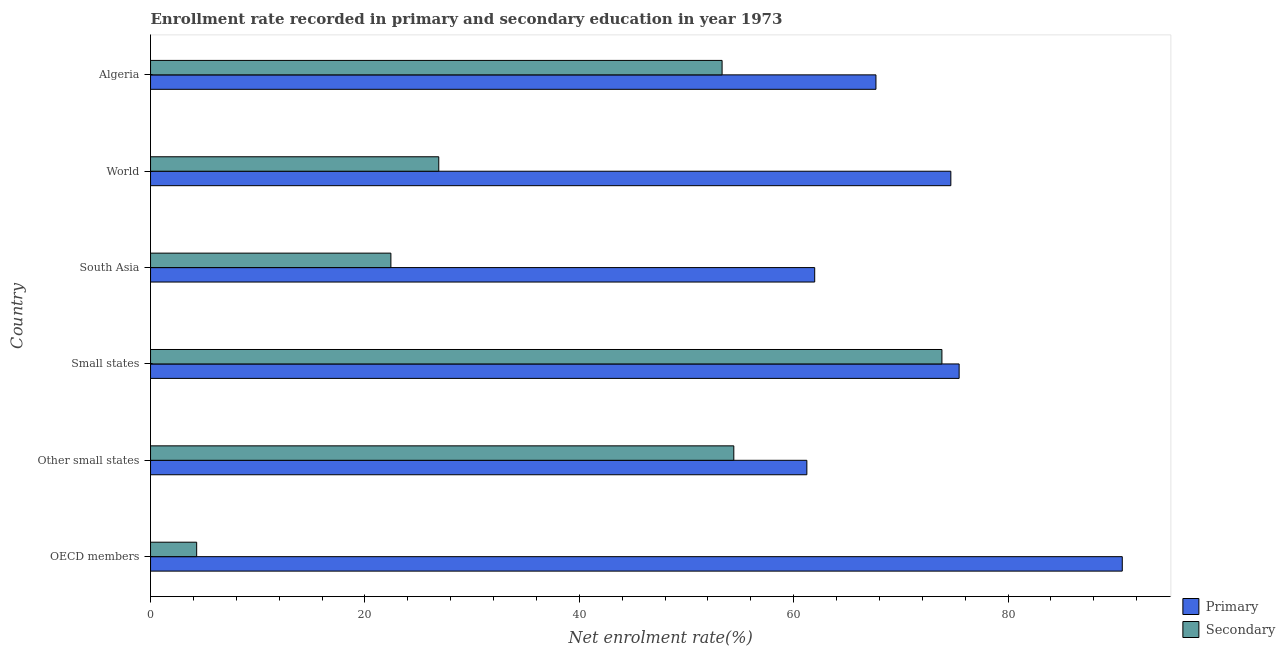How many bars are there on the 2nd tick from the top?
Offer a terse response. 2. How many bars are there on the 4th tick from the bottom?
Keep it short and to the point. 2. What is the label of the 4th group of bars from the top?
Provide a succinct answer. Small states. In how many cases, is the number of bars for a given country not equal to the number of legend labels?
Give a very brief answer. 0. What is the enrollment rate in secondary education in Small states?
Provide a short and direct response. 73.83. Across all countries, what is the maximum enrollment rate in primary education?
Your response must be concise. 90.66. Across all countries, what is the minimum enrollment rate in primary education?
Provide a short and direct response. 61.23. In which country was the enrollment rate in primary education minimum?
Offer a terse response. Other small states. What is the total enrollment rate in secondary education in the graph?
Make the answer very short. 235.18. What is the difference between the enrollment rate in secondary education in OECD members and that in Other small states?
Your response must be concise. -50.11. What is the difference between the enrollment rate in primary education in OECD members and the enrollment rate in secondary education in Algeria?
Your answer should be very brief. 37.33. What is the average enrollment rate in primary education per country?
Provide a succinct answer. 71.94. What is the difference between the enrollment rate in secondary education and enrollment rate in primary education in OECD members?
Give a very brief answer. -86.35. In how many countries, is the enrollment rate in secondary education greater than 48 %?
Make the answer very short. 3. What is the ratio of the enrollment rate in secondary education in Other small states to that in Small states?
Provide a short and direct response. 0.74. Is the difference between the enrollment rate in primary education in OECD members and Other small states greater than the difference between the enrollment rate in secondary education in OECD members and Other small states?
Make the answer very short. Yes. What is the difference between the highest and the second highest enrollment rate in secondary education?
Make the answer very short. 19.42. What is the difference between the highest and the lowest enrollment rate in primary education?
Offer a very short reply. 29.43. Is the sum of the enrollment rate in primary education in OECD members and World greater than the maximum enrollment rate in secondary education across all countries?
Provide a short and direct response. Yes. What does the 2nd bar from the top in Algeria represents?
Keep it short and to the point. Primary. What does the 2nd bar from the bottom in OECD members represents?
Offer a very short reply. Secondary. Are all the bars in the graph horizontal?
Make the answer very short. Yes. How many countries are there in the graph?
Provide a succinct answer. 6. Does the graph contain any zero values?
Offer a very short reply. No. Where does the legend appear in the graph?
Make the answer very short. Bottom right. How many legend labels are there?
Your answer should be very brief. 2. What is the title of the graph?
Provide a succinct answer. Enrollment rate recorded in primary and secondary education in year 1973. Does "Private consumption" appear as one of the legend labels in the graph?
Offer a terse response. No. What is the label or title of the X-axis?
Your answer should be compact. Net enrolment rate(%). What is the Net enrolment rate(%) in Primary in OECD members?
Offer a terse response. 90.66. What is the Net enrolment rate(%) of Secondary in OECD members?
Ensure brevity in your answer.  4.3. What is the Net enrolment rate(%) of Primary in Other small states?
Provide a succinct answer. 61.23. What is the Net enrolment rate(%) in Secondary in Other small states?
Make the answer very short. 54.41. What is the Net enrolment rate(%) in Primary in Small states?
Offer a very short reply. 75.44. What is the Net enrolment rate(%) of Secondary in Small states?
Provide a succinct answer. 73.83. What is the Net enrolment rate(%) of Primary in South Asia?
Keep it short and to the point. 61.96. What is the Net enrolment rate(%) in Secondary in South Asia?
Provide a succinct answer. 22.42. What is the Net enrolment rate(%) in Primary in World?
Your response must be concise. 74.66. What is the Net enrolment rate(%) of Secondary in World?
Your answer should be compact. 26.89. What is the Net enrolment rate(%) in Primary in Algeria?
Make the answer very short. 67.68. What is the Net enrolment rate(%) in Secondary in Algeria?
Offer a very short reply. 53.32. Across all countries, what is the maximum Net enrolment rate(%) in Primary?
Provide a short and direct response. 90.66. Across all countries, what is the maximum Net enrolment rate(%) in Secondary?
Provide a short and direct response. 73.83. Across all countries, what is the minimum Net enrolment rate(%) of Primary?
Ensure brevity in your answer.  61.23. Across all countries, what is the minimum Net enrolment rate(%) of Secondary?
Your answer should be compact. 4.3. What is the total Net enrolment rate(%) in Primary in the graph?
Offer a terse response. 431.62. What is the total Net enrolment rate(%) in Secondary in the graph?
Offer a terse response. 235.18. What is the difference between the Net enrolment rate(%) in Primary in OECD members and that in Other small states?
Provide a succinct answer. 29.43. What is the difference between the Net enrolment rate(%) in Secondary in OECD members and that in Other small states?
Ensure brevity in your answer.  -50.11. What is the difference between the Net enrolment rate(%) in Primary in OECD members and that in Small states?
Ensure brevity in your answer.  15.22. What is the difference between the Net enrolment rate(%) of Secondary in OECD members and that in Small states?
Make the answer very short. -69.53. What is the difference between the Net enrolment rate(%) in Primary in OECD members and that in South Asia?
Keep it short and to the point. 28.69. What is the difference between the Net enrolment rate(%) of Secondary in OECD members and that in South Asia?
Keep it short and to the point. -18.12. What is the difference between the Net enrolment rate(%) in Primary in OECD members and that in World?
Offer a terse response. 15.99. What is the difference between the Net enrolment rate(%) of Secondary in OECD members and that in World?
Make the answer very short. -22.59. What is the difference between the Net enrolment rate(%) in Primary in OECD members and that in Algeria?
Your answer should be very brief. 22.98. What is the difference between the Net enrolment rate(%) of Secondary in OECD members and that in Algeria?
Your response must be concise. -49.02. What is the difference between the Net enrolment rate(%) of Primary in Other small states and that in Small states?
Ensure brevity in your answer.  -14.21. What is the difference between the Net enrolment rate(%) in Secondary in Other small states and that in Small states?
Your answer should be compact. -19.42. What is the difference between the Net enrolment rate(%) in Primary in Other small states and that in South Asia?
Provide a short and direct response. -0.73. What is the difference between the Net enrolment rate(%) of Secondary in Other small states and that in South Asia?
Give a very brief answer. 31.99. What is the difference between the Net enrolment rate(%) in Primary in Other small states and that in World?
Provide a short and direct response. -13.43. What is the difference between the Net enrolment rate(%) of Secondary in Other small states and that in World?
Make the answer very short. 27.53. What is the difference between the Net enrolment rate(%) of Primary in Other small states and that in Algeria?
Your answer should be compact. -6.45. What is the difference between the Net enrolment rate(%) of Secondary in Other small states and that in Algeria?
Keep it short and to the point. 1.09. What is the difference between the Net enrolment rate(%) of Primary in Small states and that in South Asia?
Your answer should be compact. 13.47. What is the difference between the Net enrolment rate(%) in Secondary in Small states and that in South Asia?
Ensure brevity in your answer.  51.41. What is the difference between the Net enrolment rate(%) in Primary in Small states and that in World?
Make the answer very short. 0.77. What is the difference between the Net enrolment rate(%) in Secondary in Small states and that in World?
Your response must be concise. 46.94. What is the difference between the Net enrolment rate(%) in Primary in Small states and that in Algeria?
Provide a succinct answer. 7.76. What is the difference between the Net enrolment rate(%) of Secondary in Small states and that in Algeria?
Offer a very short reply. 20.51. What is the difference between the Net enrolment rate(%) in Primary in South Asia and that in World?
Provide a short and direct response. -12.7. What is the difference between the Net enrolment rate(%) of Secondary in South Asia and that in World?
Your answer should be compact. -4.47. What is the difference between the Net enrolment rate(%) in Primary in South Asia and that in Algeria?
Offer a terse response. -5.71. What is the difference between the Net enrolment rate(%) of Secondary in South Asia and that in Algeria?
Your answer should be compact. -30.9. What is the difference between the Net enrolment rate(%) in Primary in World and that in Algeria?
Provide a short and direct response. 6.99. What is the difference between the Net enrolment rate(%) in Secondary in World and that in Algeria?
Give a very brief answer. -26.43. What is the difference between the Net enrolment rate(%) of Primary in OECD members and the Net enrolment rate(%) of Secondary in Other small states?
Make the answer very short. 36.24. What is the difference between the Net enrolment rate(%) of Primary in OECD members and the Net enrolment rate(%) of Secondary in Small states?
Ensure brevity in your answer.  16.83. What is the difference between the Net enrolment rate(%) in Primary in OECD members and the Net enrolment rate(%) in Secondary in South Asia?
Offer a very short reply. 68.23. What is the difference between the Net enrolment rate(%) in Primary in OECD members and the Net enrolment rate(%) in Secondary in World?
Make the answer very short. 63.77. What is the difference between the Net enrolment rate(%) of Primary in OECD members and the Net enrolment rate(%) of Secondary in Algeria?
Your answer should be very brief. 37.33. What is the difference between the Net enrolment rate(%) in Primary in Other small states and the Net enrolment rate(%) in Secondary in Small states?
Keep it short and to the point. -12.6. What is the difference between the Net enrolment rate(%) of Primary in Other small states and the Net enrolment rate(%) of Secondary in South Asia?
Ensure brevity in your answer.  38.81. What is the difference between the Net enrolment rate(%) in Primary in Other small states and the Net enrolment rate(%) in Secondary in World?
Provide a short and direct response. 34.34. What is the difference between the Net enrolment rate(%) in Primary in Other small states and the Net enrolment rate(%) in Secondary in Algeria?
Make the answer very short. 7.91. What is the difference between the Net enrolment rate(%) in Primary in Small states and the Net enrolment rate(%) in Secondary in South Asia?
Make the answer very short. 53.01. What is the difference between the Net enrolment rate(%) in Primary in Small states and the Net enrolment rate(%) in Secondary in World?
Keep it short and to the point. 48.55. What is the difference between the Net enrolment rate(%) in Primary in Small states and the Net enrolment rate(%) in Secondary in Algeria?
Make the answer very short. 22.11. What is the difference between the Net enrolment rate(%) of Primary in South Asia and the Net enrolment rate(%) of Secondary in World?
Give a very brief answer. 35.07. What is the difference between the Net enrolment rate(%) of Primary in South Asia and the Net enrolment rate(%) of Secondary in Algeria?
Give a very brief answer. 8.64. What is the difference between the Net enrolment rate(%) of Primary in World and the Net enrolment rate(%) of Secondary in Algeria?
Provide a short and direct response. 21.34. What is the average Net enrolment rate(%) in Primary per country?
Ensure brevity in your answer.  71.94. What is the average Net enrolment rate(%) of Secondary per country?
Keep it short and to the point. 39.2. What is the difference between the Net enrolment rate(%) of Primary and Net enrolment rate(%) of Secondary in OECD members?
Your response must be concise. 86.35. What is the difference between the Net enrolment rate(%) of Primary and Net enrolment rate(%) of Secondary in Other small states?
Provide a succinct answer. 6.82. What is the difference between the Net enrolment rate(%) of Primary and Net enrolment rate(%) of Secondary in Small states?
Ensure brevity in your answer.  1.61. What is the difference between the Net enrolment rate(%) in Primary and Net enrolment rate(%) in Secondary in South Asia?
Keep it short and to the point. 39.54. What is the difference between the Net enrolment rate(%) in Primary and Net enrolment rate(%) in Secondary in World?
Offer a very short reply. 47.77. What is the difference between the Net enrolment rate(%) in Primary and Net enrolment rate(%) in Secondary in Algeria?
Offer a very short reply. 14.35. What is the ratio of the Net enrolment rate(%) in Primary in OECD members to that in Other small states?
Keep it short and to the point. 1.48. What is the ratio of the Net enrolment rate(%) in Secondary in OECD members to that in Other small states?
Provide a succinct answer. 0.08. What is the ratio of the Net enrolment rate(%) of Primary in OECD members to that in Small states?
Ensure brevity in your answer.  1.2. What is the ratio of the Net enrolment rate(%) of Secondary in OECD members to that in Small states?
Keep it short and to the point. 0.06. What is the ratio of the Net enrolment rate(%) in Primary in OECD members to that in South Asia?
Ensure brevity in your answer.  1.46. What is the ratio of the Net enrolment rate(%) of Secondary in OECD members to that in South Asia?
Offer a terse response. 0.19. What is the ratio of the Net enrolment rate(%) of Primary in OECD members to that in World?
Your answer should be compact. 1.21. What is the ratio of the Net enrolment rate(%) in Secondary in OECD members to that in World?
Your answer should be very brief. 0.16. What is the ratio of the Net enrolment rate(%) in Primary in OECD members to that in Algeria?
Make the answer very short. 1.34. What is the ratio of the Net enrolment rate(%) in Secondary in OECD members to that in Algeria?
Offer a very short reply. 0.08. What is the ratio of the Net enrolment rate(%) in Primary in Other small states to that in Small states?
Your answer should be compact. 0.81. What is the ratio of the Net enrolment rate(%) in Secondary in Other small states to that in Small states?
Provide a short and direct response. 0.74. What is the ratio of the Net enrolment rate(%) of Primary in Other small states to that in South Asia?
Your response must be concise. 0.99. What is the ratio of the Net enrolment rate(%) in Secondary in Other small states to that in South Asia?
Your answer should be very brief. 2.43. What is the ratio of the Net enrolment rate(%) in Primary in Other small states to that in World?
Your response must be concise. 0.82. What is the ratio of the Net enrolment rate(%) in Secondary in Other small states to that in World?
Make the answer very short. 2.02. What is the ratio of the Net enrolment rate(%) of Primary in Other small states to that in Algeria?
Give a very brief answer. 0.9. What is the ratio of the Net enrolment rate(%) of Secondary in Other small states to that in Algeria?
Ensure brevity in your answer.  1.02. What is the ratio of the Net enrolment rate(%) of Primary in Small states to that in South Asia?
Your response must be concise. 1.22. What is the ratio of the Net enrolment rate(%) of Secondary in Small states to that in South Asia?
Provide a succinct answer. 3.29. What is the ratio of the Net enrolment rate(%) of Primary in Small states to that in World?
Give a very brief answer. 1.01. What is the ratio of the Net enrolment rate(%) of Secondary in Small states to that in World?
Keep it short and to the point. 2.75. What is the ratio of the Net enrolment rate(%) of Primary in Small states to that in Algeria?
Provide a short and direct response. 1.11. What is the ratio of the Net enrolment rate(%) in Secondary in Small states to that in Algeria?
Provide a short and direct response. 1.38. What is the ratio of the Net enrolment rate(%) in Primary in South Asia to that in World?
Give a very brief answer. 0.83. What is the ratio of the Net enrolment rate(%) of Secondary in South Asia to that in World?
Give a very brief answer. 0.83. What is the ratio of the Net enrolment rate(%) in Primary in South Asia to that in Algeria?
Provide a short and direct response. 0.92. What is the ratio of the Net enrolment rate(%) in Secondary in South Asia to that in Algeria?
Your answer should be very brief. 0.42. What is the ratio of the Net enrolment rate(%) of Primary in World to that in Algeria?
Make the answer very short. 1.1. What is the ratio of the Net enrolment rate(%) of Secondary in World to that in Algeria?
Keep it short and to the point. 0.5. What is the difference between the highest and the second highest Net enrolment rate(%) in Primary?
Your answer should be very brief. 15.22. What is the difference between the highest and the second highest Net enrolment rate(%) of Secondary?
Give a very brief answer. 19.42. What is the difference between the highest and the lowest Net enrolment rate(%) of Primary?
Offer a terse response. 29.43. What is the difference between the highest and the lowest Net enrolment rate(%) of Secondary?
Offer a terse response. 69.53. 